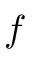Convert formula to latex. <formula><loc_0><loc_0><loc_500><loc_500>f</formula> 